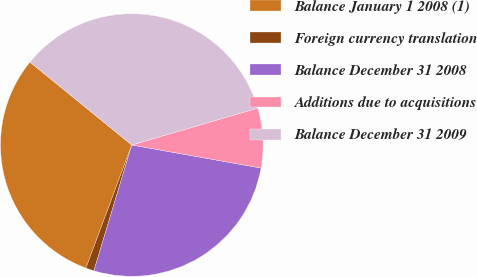Convert chart to OTSL. <chart><loc_0><loc_0><loc_500><loc_500><pie_chart><fcel>Balance January 1 2008 (1)<fcel>Foreign currency translation<fcel>Balance December 31 2008<fcel>Additions due to acquisitions<fcel>Balance December 31 2009<nl><fcel>30.21%<fcel>1.02%<fcel>26.85%<fcel>7.34%<fcel>34.59%<nl></chart> 